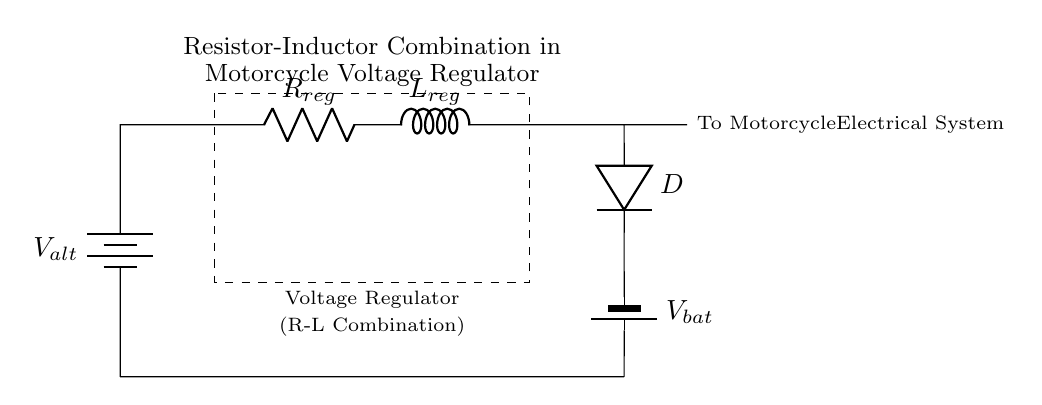What components are present in the circuit? The components in the circuit are a resistor, an inductor, a diode, and two batteries (one alternative and one for the battery).
Answer: Resistor, Inductor, Diode, Batteries What is the role of the resistor in this circuit? The resistor in this circuit helps to limit the current flowing into the inductor, which stabilizes the voltage output and protects the circuit from excessive current.
Answer: Current limiting What does the inductor do in this voltage regulator circuit? The inductor stores energy in a magnetic field when current passes through it, helping to smooth out the electrical output and reduce voltage fluctuations.
Answer: Energy storage, voltage smoothing What is the function of the diode in this circuit? The diode allows current to flow in one direction only, preventing backflow into the voltage regulator and ensuring stable power delivery from the battery.
Answer: Current direction control How does the combination of resistor and inductor influence voltage regulation? The combination of the resistor and inductor creates a low-pass filter effect, which reduces voltage spikes and ensures a more constant voltage level to the motorcycle's electrical system.
Answer: Low-pass filter effect What type of voltage source is used in the circuit for the motorcycle? The voltage source used in this circuit for the motorcycle is a battery, specifically referred to as V_bat in the diagram.
Answer: Battery 